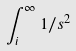Convert formula to latex. <formula><loc_0><loc_0><loc_500><loc_500>\int _ { i } ^ { \infty } 1 / s ^ { 2 }</formula> 